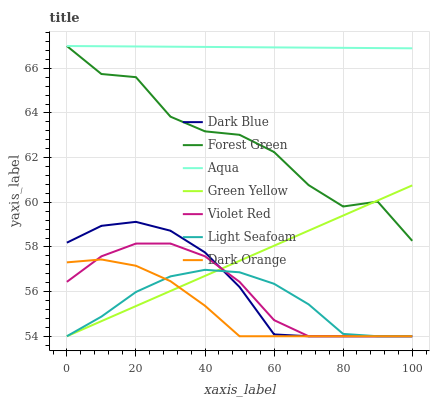Does Dark Orange have the minimum area under the curve?
Answer yes or no. Yes. Does Aqua have the maximum area under the curve?
Answer yes or no. Yes. Does Violet Red have the minimum area under the curve?
Answer yes or no. No. Does Violet Red have the maximum area under the curve?
Answer yes or no. No. Is Green Yellow the smoothest?
Answer yes or no. Yes. Is Forest Green the roughest?
Answer yes or no. Yes. Is Violet Red the smoothest?
Answer yes or no. No. Is Violet Red the roughest?
Answer yes or no. No. Does Dark Orange have the lowest value?
Answer yes or no. Yes. Does Aqua have the lowest value?
Answer yes or no. No. Does Forest Green have the highest value?
Answer yes or no. Yes. Does Violet Red have the highest value?
Answer yes or no. No. Is Light Seafoam less than Aqua?
Answer yes or no. Yes. Is Forest Green greater than Dark Blue?
Answer yes or no. Yes. Does Violet Red intersect Dark Blue?
Answer yes or no. Yes. Is Violet Red less than Dark Blue?
Answer yes or no. No. Is Violet Red greater than Dark Blue?
Answer yes or no. No. Does Light Seafoam intersect Aqua?
Answer yes or no. No. 